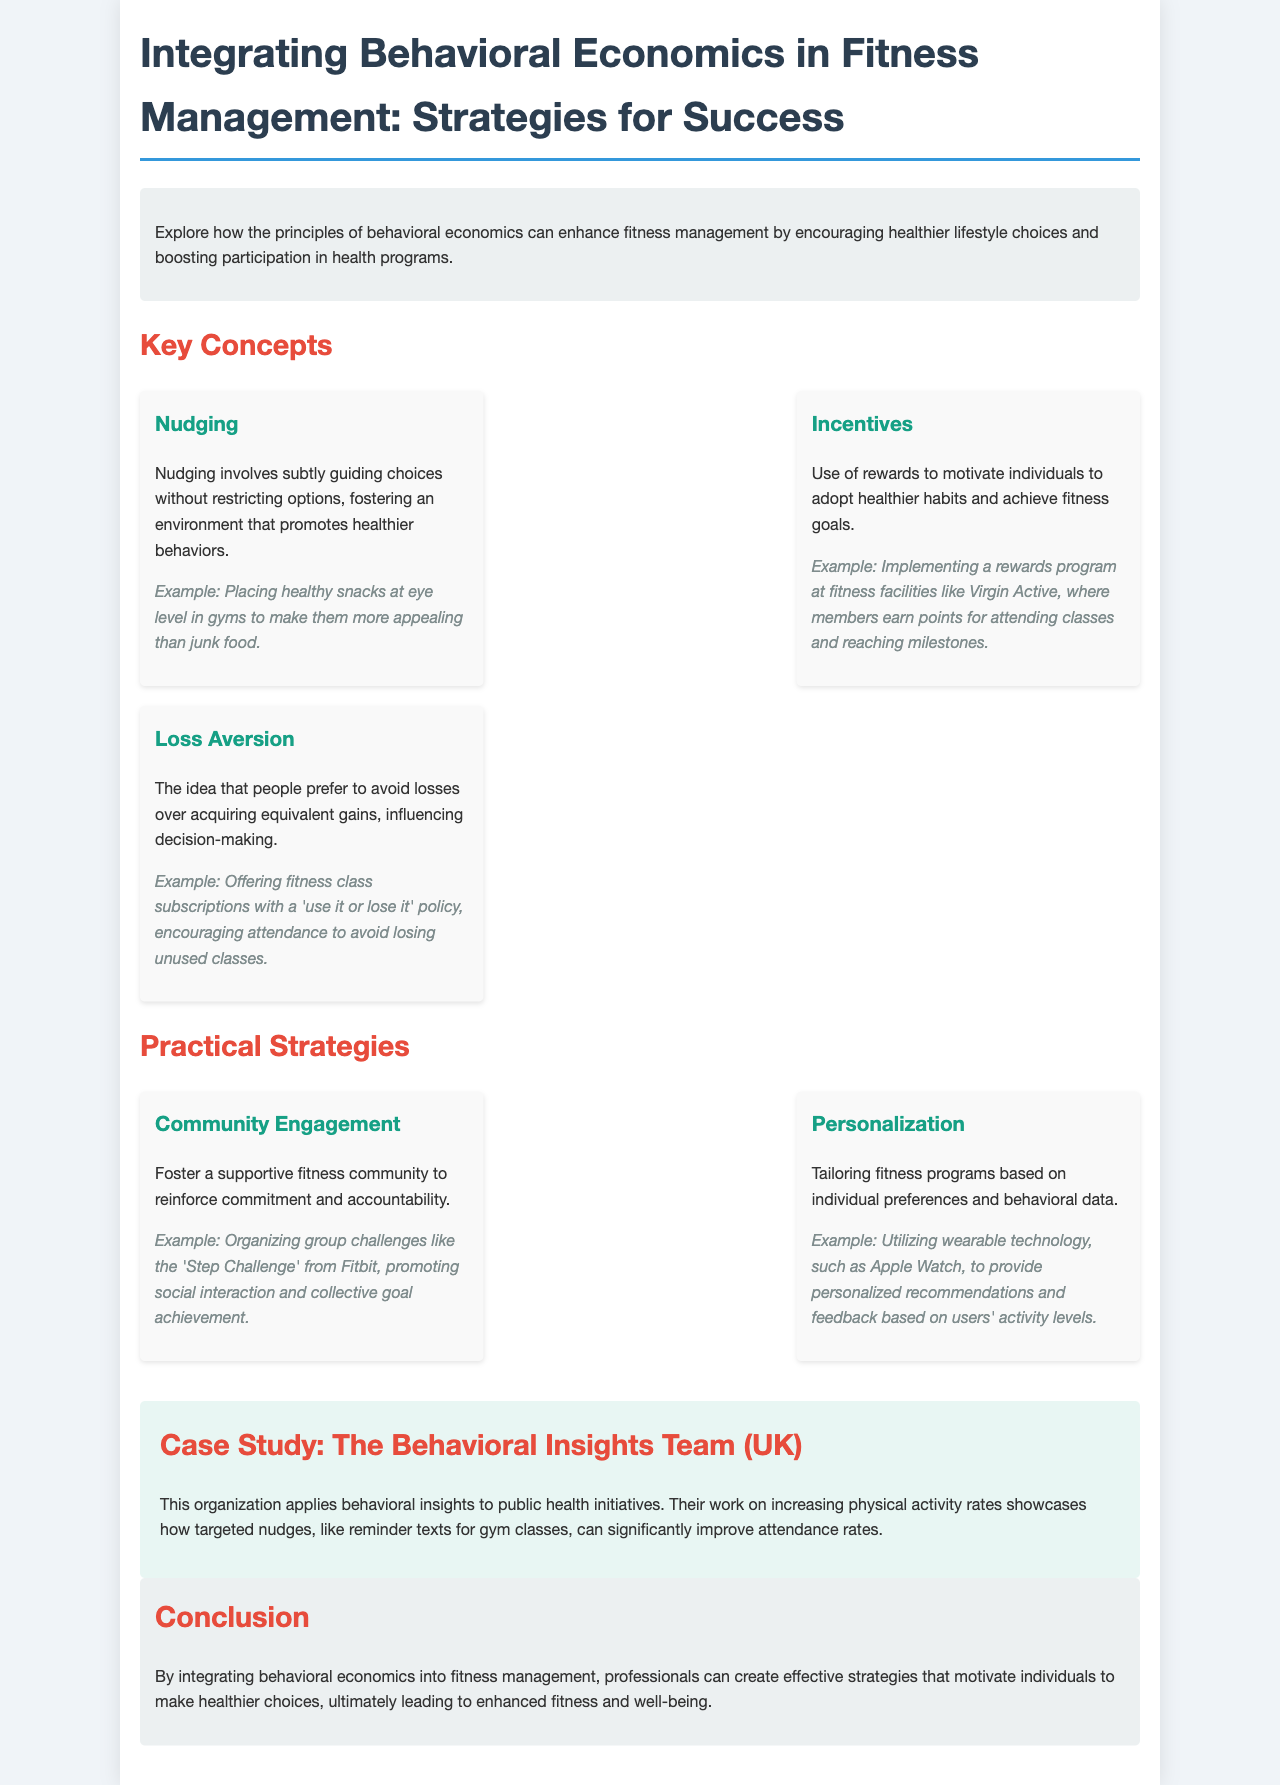What is the title of the document? The title of the document is highlighted in the header section, clearly showing the main topic of the content.
Answer: Integrating Behavioral Economics in Fitness Management: Strategies for Success What are the three key concepts listed? The document provides a summary of three essential concepts under the "Key Concepts" section.
Answer: Nudging, Incentives, Loss Aversion What is an example of nudging? The document includes an example to illustrate the concept of nudging under its description.
Answer: Placing healthy snacks at eye level in gyms How does the Behavioral Insights Team apply behavioral economics? The document describes a specific case study showcasing the application of behavioral insights in public health.
Answer: Increasing physical activity rates What is one practical strategy mentioned in the document? The document outlines practical strategies that incorporate behavioral economics principles.
Answer: Community Engagement What is the primary goal of integrating behavioral economics in fitness management? The conclusion summarizes the overall objective stated in the document.
Answer: Enhance fitness and well-being What reward system is mentioned in the context of fitness facilities? The document provides a specific example of a rewards program related to fitness facilities to motivate individuals.
Answer: Points for attending classes What color is used for the section headers in the document? The document specifies the color scheme used for the various headers in the brochure.
Answer: #2c3e50 